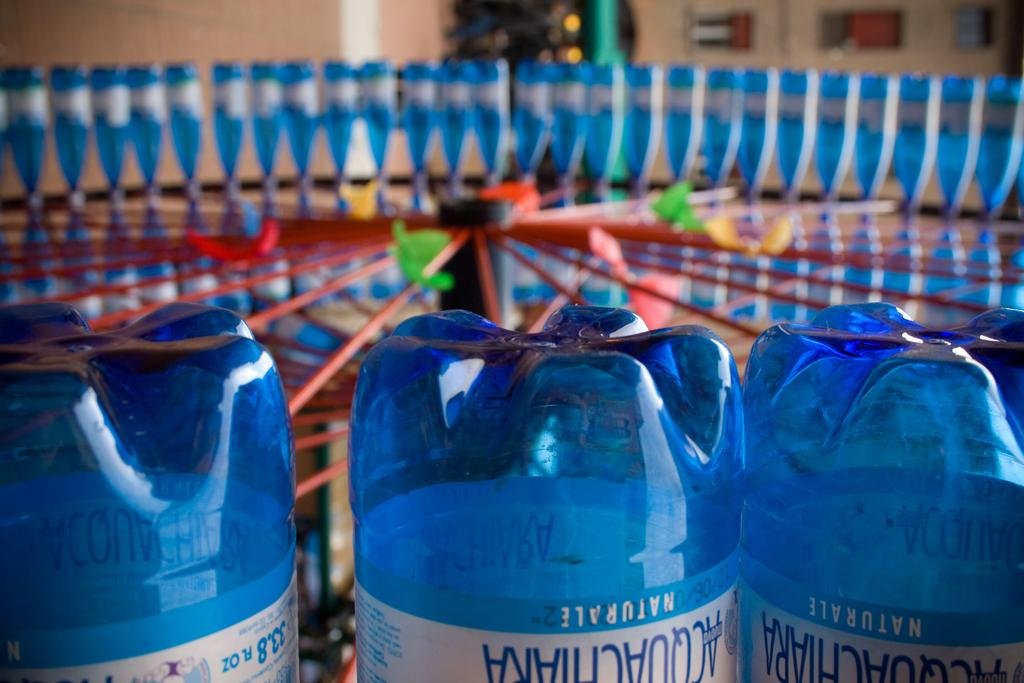What is the main subject of the image? The main subject of the image is many bottles. What can be said about the color of the bottles? The bottles are blue in color. How many pigs can be seen in the image? There are no pigs present in the image. What is the texture of the chin of the bottle in the image? Bottles do not have chins, as they are inanimate objects. 